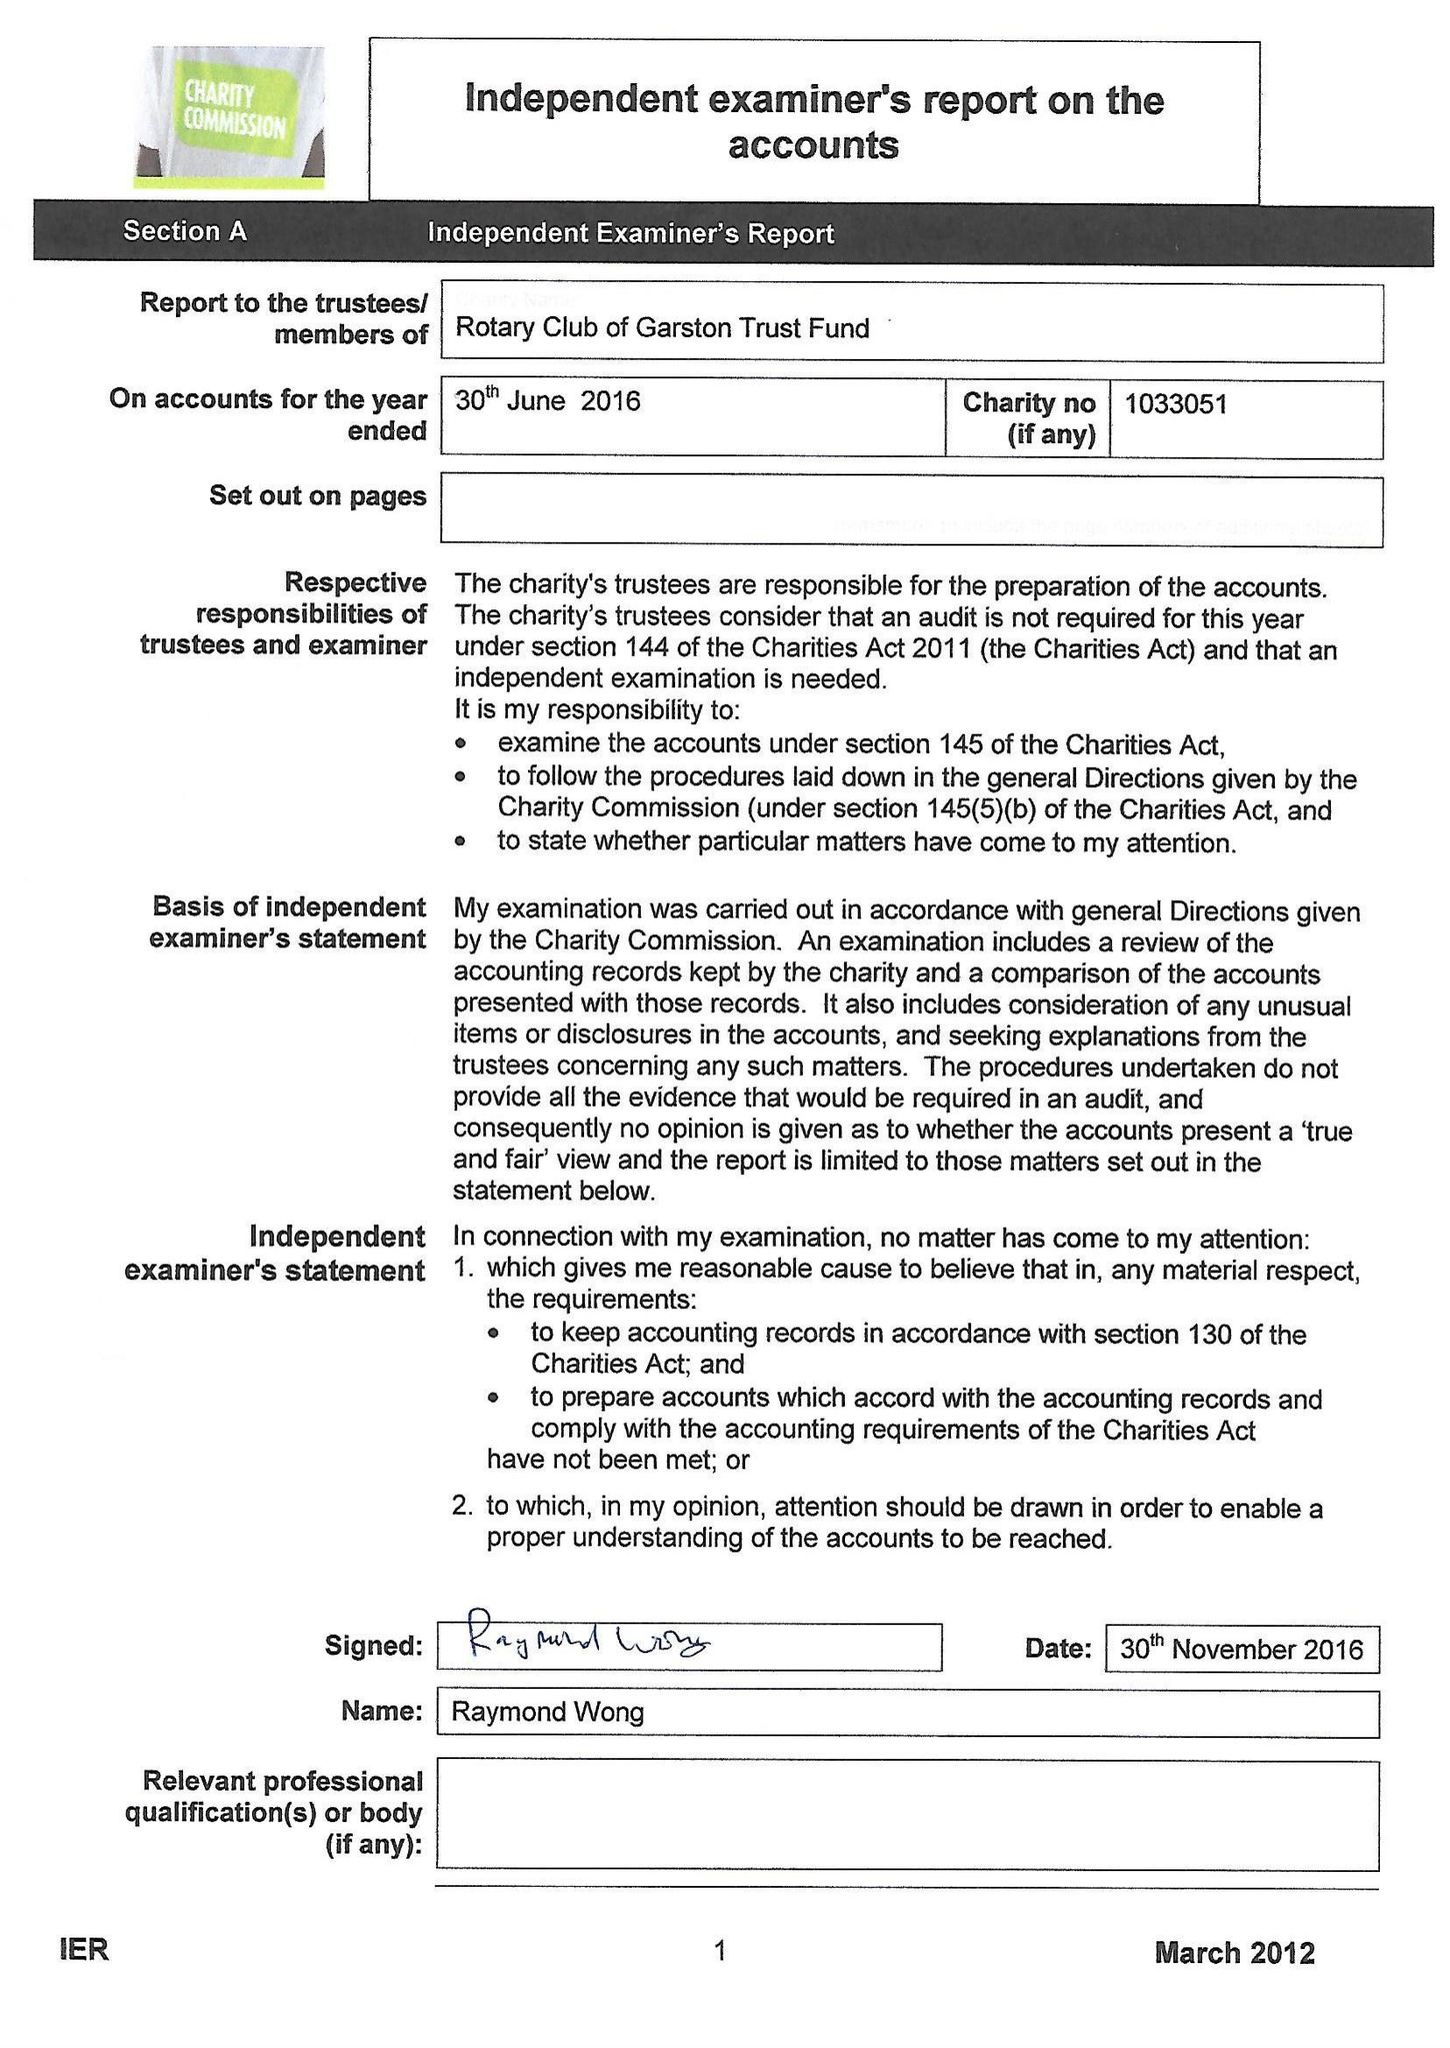What is the value for the report_date?
Answer the question using a single word or phrase. 2016-06-30 